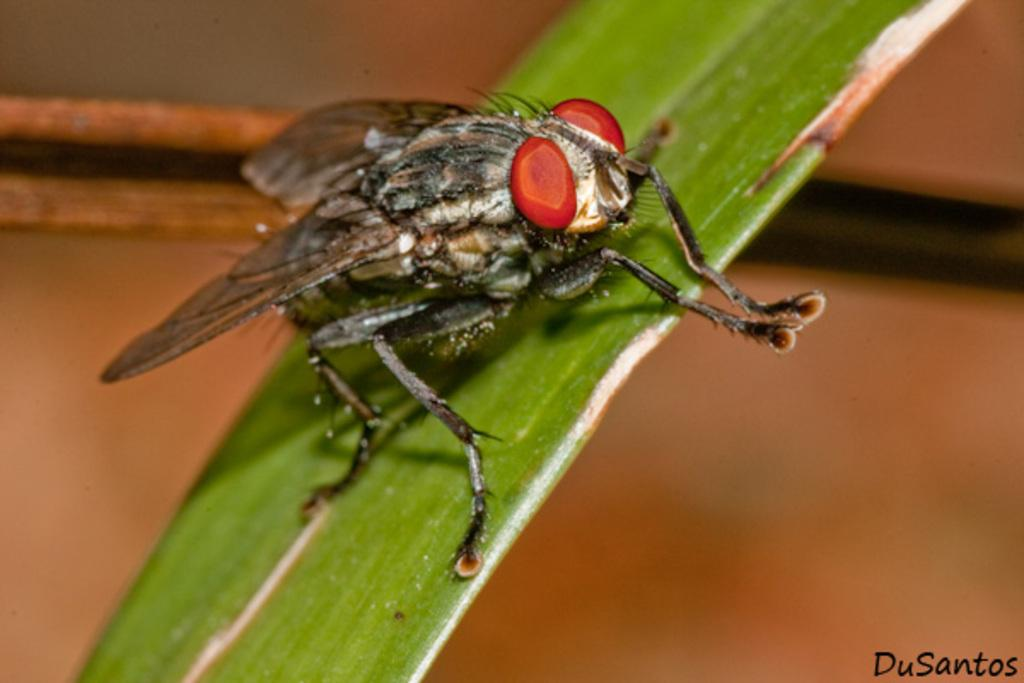What is the main subject of the image? The main subject of the image is a fly on a leaf. Where is the fly located in relation to the leaf? The fly is located in the center of the leaf. How many oranges are being used as a base for the card in the image? There are no oranges or cards present in the image; it features a fly on a leaf. 